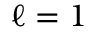<formula> <loc_0><loc_0><loc_500><loc_500>\ell = 1</formula> 